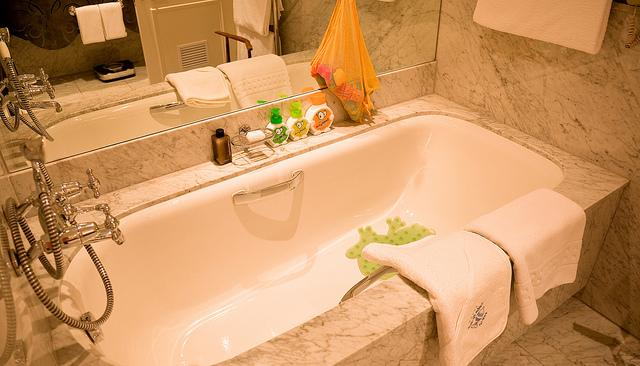Who likely uses this bathtub?

Choices:
A) adults
B) animals
C) children
D) teenagers children 